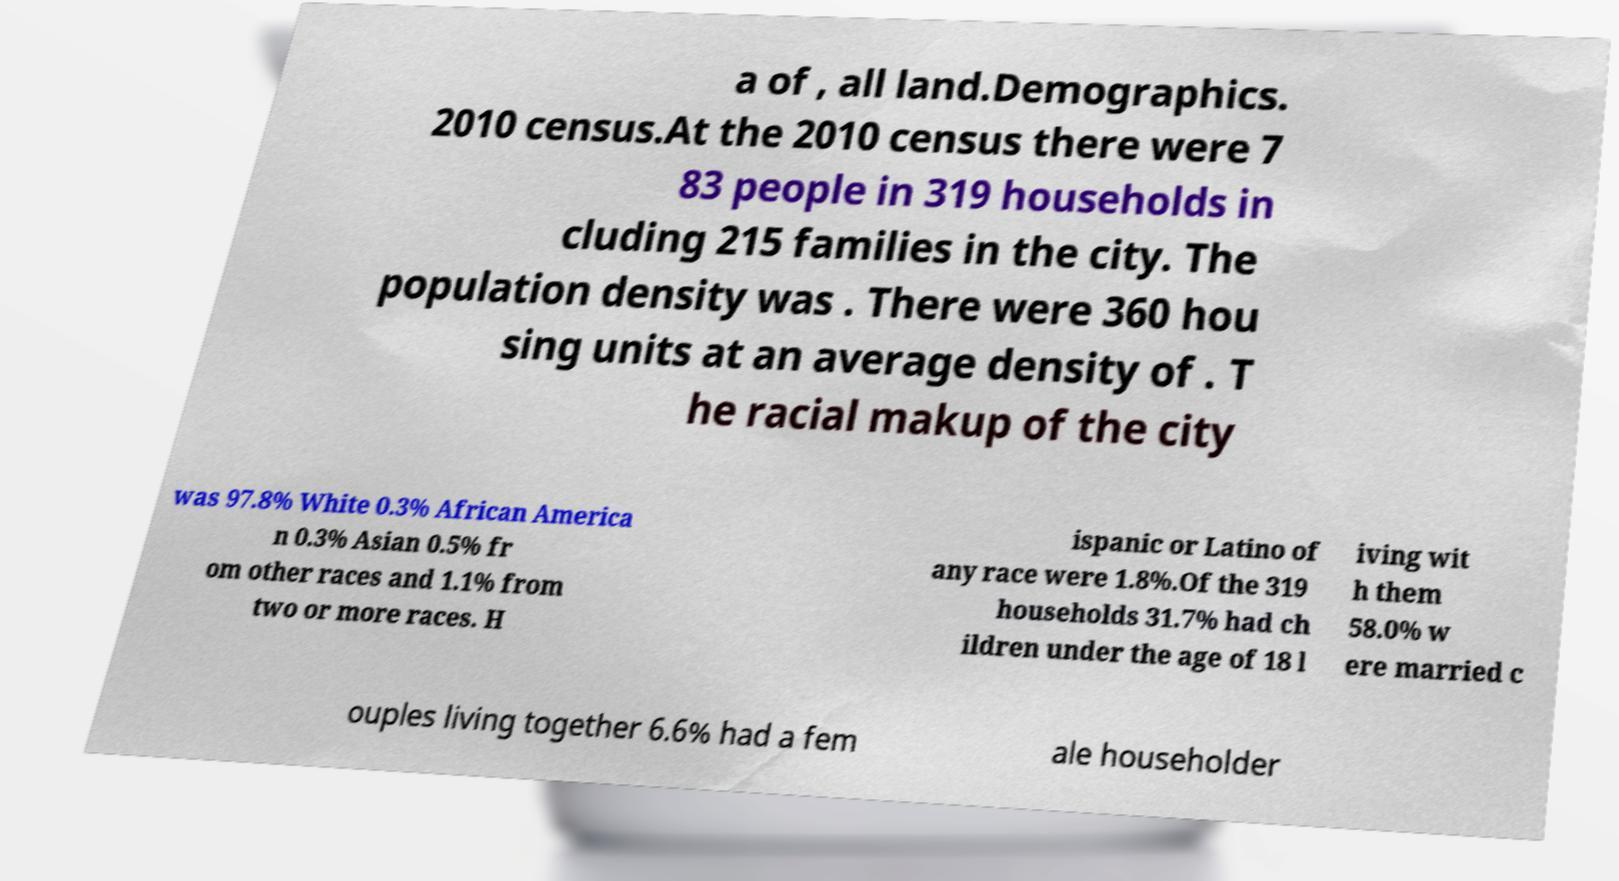Please read and relay the text visible in this image. What does it say? a of , all land.Demographics. 2010 census.At the 2010 census there were 7 83 people in 319 households in cluding 215 families in the city. The population density was . There were 360 hou sing units at an average density of . T he racial makup of the city was 97.8% White 0.3% African America n 0.3% Asian 0.5% fr om other races and 1.1% from two or more races. H ispanic or Latino of any race were 1.8%.Of the 319 households 31.7% had ch ildren under the age of 18 l iving wit h them 58.0% w ere married c ouples living together 6.6% had a fem ale householder 